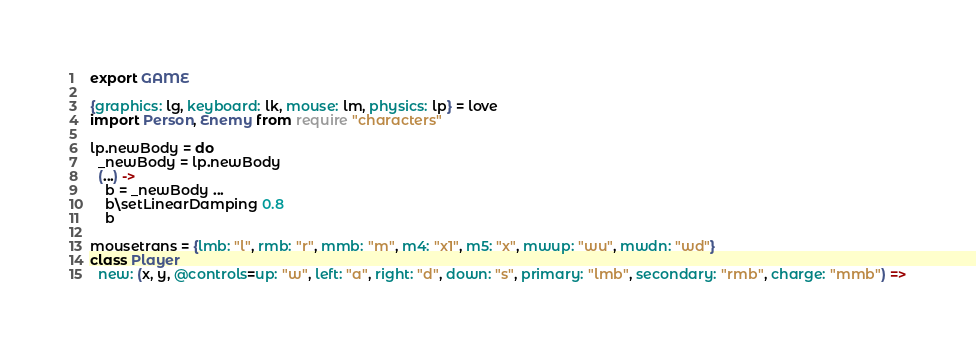<code> <loc_0><loc_0><loc_500><loc_500><_MoonScript_>export GAME

{graphics: lg, keyboard: lk, mouse: lm, physics: lp} = love
import Person, Enemy from require "characters"

lp.newBody = do
  _newBody = lp.newBody
  (...) ->
    b = _newBody ...
    b\setLinearDamping 0.8
    b

mousetrans = {lmb: "l", rmb: "r", mmb: "m", m4: "x1", m5: "x", mwup: "wu", mwdn: "wd"}
class Player
  new: (x, y, @controls=up: "w", left: "a", right: "d", down: "s", primary: "lmb", secondary: "rmb", charge: "mmb") =></code> 